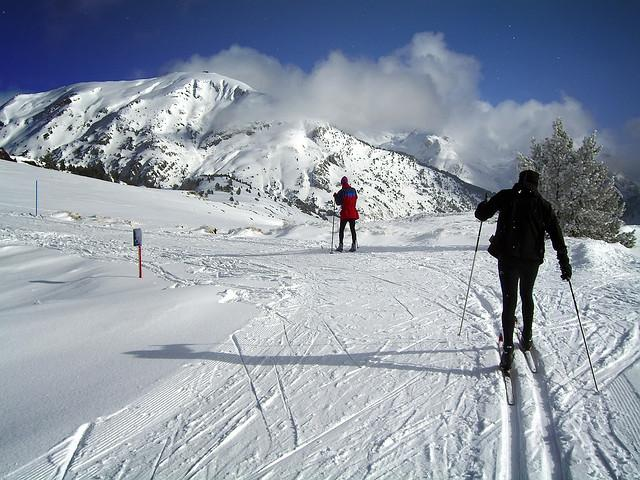What is misting up from the mountain? Please explain your reasoning. fog. Fog is misting. 